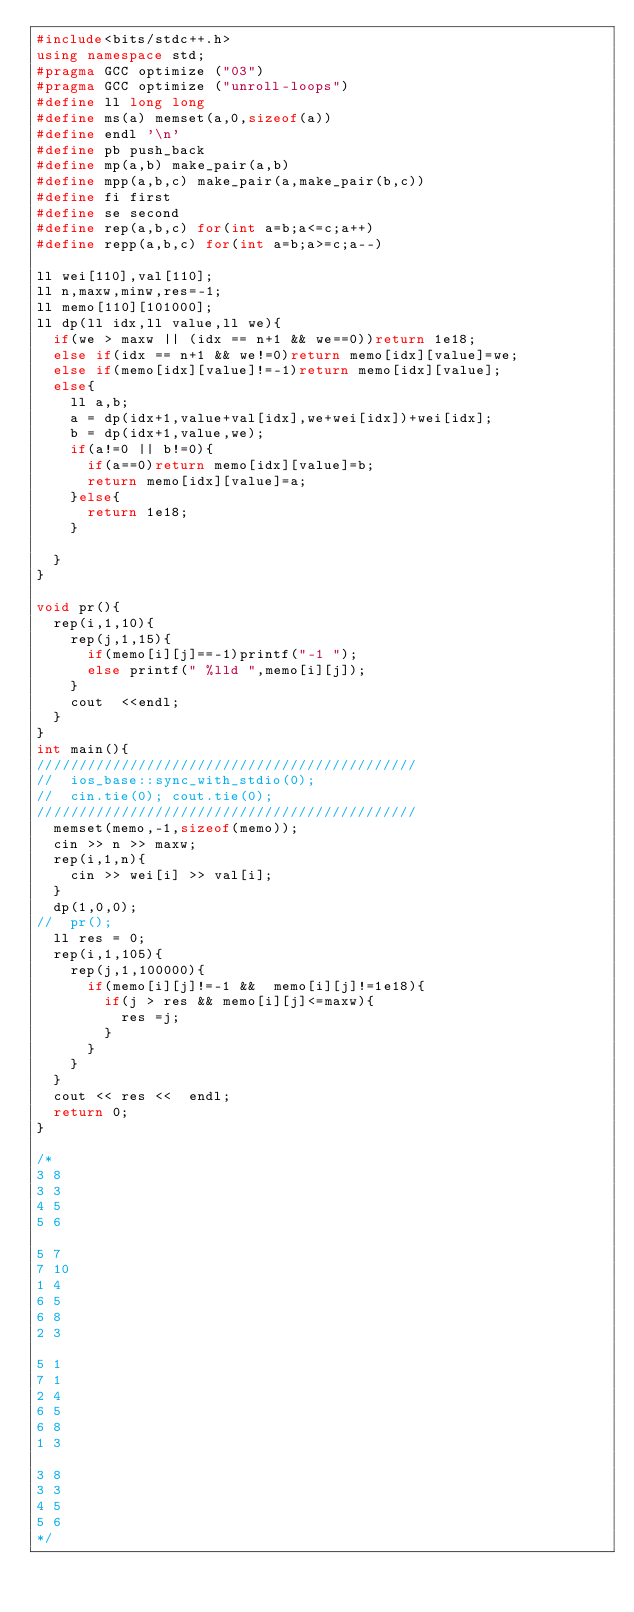Convert code to text. <code><loc_0><loc_0><loc_500><loc_500><_C++_>#include<bits/stdc++.h>
using namespace std;
#pragma GCC optimize ("03")
#pragma GCC optimize ("unroll-loops")
#define ll long long
#define ms(a) memset(a,0,sizeof(a))
#define endl '\n'
#define pb push_back
#define mp(a,b) make_pair(a,b)
#define mpp(a,b,c) make_pair(a,make_pair(b,c))
#define fi first
#define se second
#define rep(a,b,c) for(int a=b;a<=c;a++)
#define repp(a,b,c) for(int a=b;a>=c;a--)

ll wei[110],val[110];
ll n,maxw,minw,res=-1;
ll memo[110][101000];
ll dp(ll idx,ll value,ll we){
	if(we > maxw || (idx == n+1 && we==0))return 1e18;
	else if(idx == n+1 && we!=0)return memo[idx][value]=we;
	else if(memo[idx][value]!=-1)return memo[idx][value];
	else{
		ll a,b;
		a = dp(idx+1,value+val[idx],we+wei[idx])+wei[idx];
		b = dp(idx+1,value,we);
		if(a!=0 || b!=0){
			if(a==0)return memo[idx][value]=b;
			return memo[idx][value]=a;	
		}else{
			return 1e18;
		}
		
	}
}

void pr(){
	rep(i,1,10){
		rep(j,1,15){
			if(memo[i][j]==-1)printf("-1 ");
			else printf(" %lld ",memo[i][j]);
		}
		cout  <<endl;
	}		
}
int main(){
/////////////////////////////////////////////
//	ios_base::sync_with_stdio(0);
//	cin.tie(0); cout.tie(0);
/////////////////////////////////////////////
	memset(memo,-1,sizeof(memo));
	cin >> n >> maxw;
	rep(i,1,n){
		cin >> wei[i] >> val[i];
	}
	dp(1,0,0);
//	pr();
	ll res = 0;
	rep(i,1,105){
		rep(j,1,100000){
			if(memo[i][j]!=-1 &&  memo[i][j]!=1e18){
				if(j > res && memo[i][j]<=maxw){
					res =j;
				}
			}
		}
	}
	cout << res <<  endl;
	return 0;
}

/*
3 8
3 3
4 5
5 6

5 7
7 10
1 4
6 5
6 8
2 3

5 1
7 1
2 4
6 5
6 8
1 3

3 8
3 3
4 5
5 6
*/</code> 